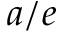<formula> <loc_0><loc_0><loc_500><loc_500>a / e</formula> 